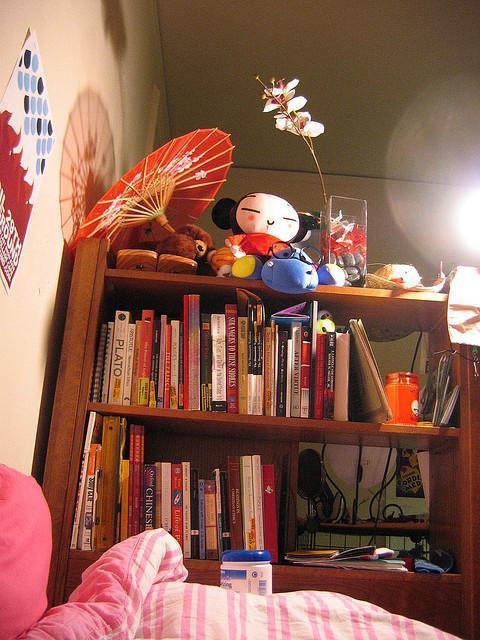How many giraffes are in the picture?
Give a very brief answer. 0. 